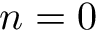Convert formula to latex. <formula><loc_0><loc_0><loc_500><loc_500>n = 0</formula> 